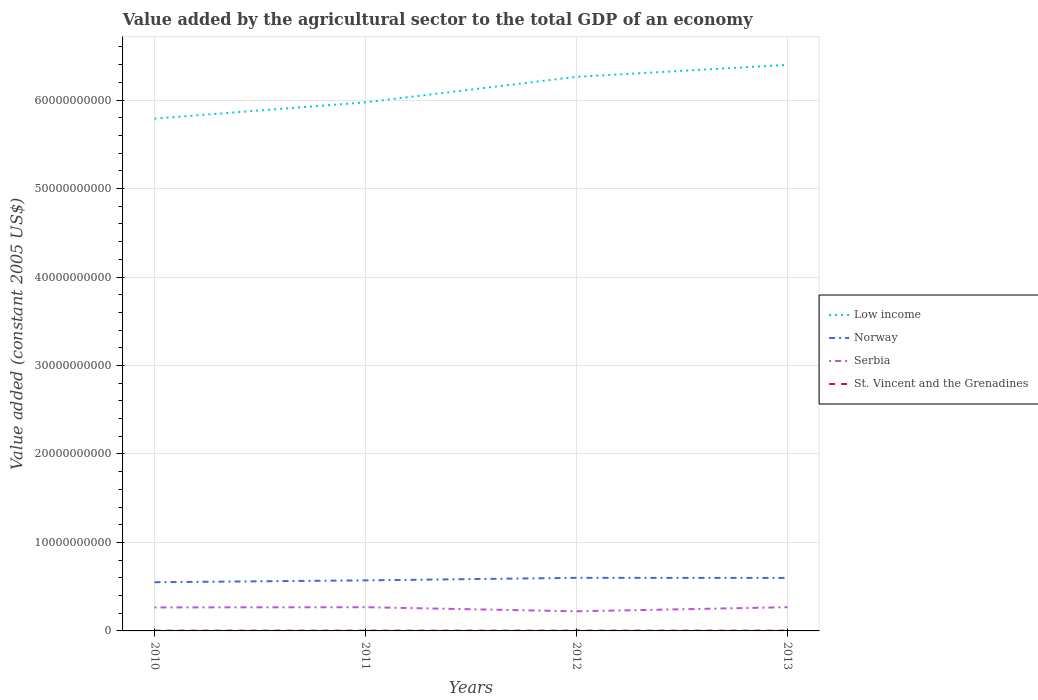Is the number of lines equal to the number of legend labels?
Your answer should be compact. Yes. Across all years, what is the maximum value added by the agricultural sector in Serbia?
Offer a terse response. 2.22e+09. What is the total value added by the agricultural sector in Norway in the graph?
Provide a short and direct response. -2.09e+08. What is the difference between the highest and the second highest value added by the agricultural sector in St. Vincent and the Grenadines?
Your response must be concise. 2.18e+06. What is the difference between the highest and the lowest value added by the agricultural sector in St. Vincent and the Grenadines?
Keep it short and to the point. 1. Is the value added by the agricultural sector in Norway strictly greater than the value added by the agricultural sector in Serbia over the years?
Offer a very short reply. No. What is the difference between two consecutive major ticks on the Y-axis?
Make the answer very short. 1.00e+1. Are the values on the major ticks of Y-axis written in scientific E-notation?
Keep it short and to the point. No. What is the title of the graph?
Ensure brevity in your answer.  Value added by the agricultural sector to the total GDP of an economy. What is the label or title of the X-axis?
Offer a very short reply. Years. What is the label or title of the Y-axis?
Give a very brief answer. Value added (constant 2005 US$). What is the Value added (constant 2005 US$) of Low income in 2010?
Offer a terse response. 5.79e+1. What is the Value added (constant 2005 US$) of Norway in 2010?
Provide a short and direct response. 5.50e+09. What is the Value added (constant 2005 US$) of Serbia in 2010?
Provide a short and direct response. 2.66e+09. What is the Value added (constant 2005 US$) of St. Vincent and the Grenadines in 2010?
Your answer should be very brief. 3.16e+07. What is the Value added (constant 2005 US$) in Low income in 2011?
Your response must be concise. 5.97e+1. What is the Value added (constant 2005 US$) of Norway in 2011?
Offer a very short reply. 5.71e+09. What is the Value added (constant 2005 US$) in Serbia in 2011?
Your answer should be very brief. 2.68e+09. What is the Value added (constant 2005 US$) of St. Vincent and the Grenadines in 2011?
Your response must be concise. 3.15e+07. What is the Value added (constant 2005 US$) in Low income in 2012?
Offer a very short reply. 6.26e+1. What is the Value added (constant 2005 US$) in Norway in 2012?
Ensure brevity in your answer.  6.00e+09. What is the Value added (constant 2005 US$) of Serbia in 2012?
Offer a terse response. 2.22e+09. What is the Value added (constant 2005 US$) of St. Vincent and the Grenadines in 2012?
Offer a very short reply. 3.18e+07. What is the Value added (constant 2005 US$) in Low income in 2013?
Give a very brief answer. 6.40e+1. What is the Value added (constant 2005 US$) of Norway in 2013?
Give a very brief answer. 5.99e+09. What is the Value added (constant 2005 US$) in Serbia in 2013?
Your response must be concise. 2.68e+09. What is the Value added (constant 2005 US$) in St. Vincent and the Grenadines in 2013?
Make the answer very short. 3.37e+07. Across all years, what is the maximum Value added (constant 2005 US$) of Low income?
Your answer should be very brief. 6.40e+1. Across all years, what is the maximum Value added (constant 2005 US$) in Norway?
Provide a succinct answer. 6.00e+09. Across all years, what is the maximum Value added (constant 2005 US$) in Serbia?
Ensure brevity in your answer.  2.68e+09. Across all years, what is the maximum Value added (constant 2005 US$) of St. Vincent and the Grenadines?
Give a very brief answer. 3.37e+07. Across all years, what is the minimum Value added (constant 2005 US$) in Low income?
Provide a short and direct response. 5.79e+1. Across all years, what is the minimum Value added (constant 2005 US$) of Norway?
Make the answer very short. 5.50e+09. Across all years, what is the minimum Value added (constant 2005 US$) of Serbia?
Give a very brief answer. 2.22e+09. Across all years, what is the minimum Value added (constant 2005 US$) in St. Vincent and the Grenadines?
Provide a short and direct response. 3.15e+07. What is the total Value added (constant 2005 US$) of Low income in the graph?
Offer a terse response. 2.44e+11. What is the total Value added (constant 2005 US$) of Norway in the graph?
Offer a terse response. 2.32e+1. What is the total Value added (constant 2005 US$) of Serbia in the graph?
Your response must be concise. 1.02e+1. What is the total Value added (constant 2005 US$) in St. Vincent and the Grenadines in the graph?
Your answer should be compact. 1.29e+08. What is the difference between the Value added (constant 2005 US$) in Low income in 2010 and that in 2011?
Keep it short and to the point. -1.84e+09. What is the difference between the Value added (constant 2005 US$) in Norway in 2010 and that in 2011?
Ensure brevity in your answer.  -2.09e+08. What is the difference between the Value added (constant 2005 US$) in Serbia in 2010 and that in 2011?
Offer a very short reply. -2.52e+07. What is the difference between the Value added (constant 2005 US$) in St. Vincent and the Grenadines in 2010 and that in 2011?
Offer a very short reply. 5.09e+04. What is the difference between the Value added (constant 2005 US$) of Low income in 2010 and that in 2012?
Offer a very short reply. -4.72e+09. What is the difference between the Value added (constant 2005 US$) in Norway in 2010 and that in 2012?
Give a very brief answer. -4.95e+08. What is the difference between the Value added (constant 2005 US$) in Serbia in 2010 and that in 2012?
Provide a succinct answer. 4.38e+08. What is the difference between the Value added (constant 2005 US$) in St. Vincent and the Grenadines in 2010 and that in 2012?
Provide a succinct answer. -2.66e+05. What is the difference between the Value added (constant 2005 US$) in Low income in 2010 and that in 2013?
Ensure brevity in your answer.  -6.07e+09. What is the difference between the Value added (constant 2005 US$) in Norway in 2010 and that in 2013?
Offer a terse response. -4.85e+08. What is the difference between the Value added (constant 2005 US$) in Serbia in 2010 and that in 2013?
Provide a short and direct response. -2.53e+07. What is the difference between the Value added (constant 2005 US$) in St. Vincent and the Grenadines in 2010 and that in 2013?
Offer a very short reply. -2.13e+06. What is the difference between the Value added (constant 2005 US$) in Low income in 2011 and that in 2012?
Keep it short and to the point. -2.88e+09. What is the difference between the Value added (constant 2005 US$) of Norway in 2011 and that in 2012?
Offer a terse response. -2.86e+08. What is the difference between the Value added (constant 2005 US$) of Serbia in 2011 and that in 2012?
Provide a short and direct response. 4.64e+08. What is the difference between the Value added (constant 2005 US$) of St. Vincent and the Grenadines in 2011 and that in 2012?
Keep it short and to the point. -3.17e+05. What is the difference between the Value added (constant 2005 US$) in Low income in 2011 and that in 2013?
Offer a terse response. -4.23e+09. What is the difference between the Value added (constant 2005 US$) in Norway in 2011 and that in 2013?
Give a very brief answer. -2.76e+08. What is the difference between the Value added (constant 2005 US$) of Serbia in 2011 and that in 2013?
Provide a succinct answer. -1.08e+05. What is the difference between the Value added (constant 2005 US$) of St. Vincent and the Grenadines in 2011 and that in 2013?
Offer a very short reply. -2.18e+06. What is the difference between the Value added (constant 2005 US$) of Low income in 2012 and that in 2013?
Give a very brief answer. -1.35e+09. What is the difference between the Value added (constant 2005 US$) in Norway in 2012 and that in 2013?
Keep it short and to the point. 9.78e+06. What is the difference between the Value added (constant 2005 US$) in Serbia in 2012 and that in 2013?
Your answer should be compact. -4.64e+08. What is the difference between the Value added (constant 2005 US$) in St. Vincent and the Grenadines in 2012 and that in 2013?
Make the answer very short. -1.86e+06. What is the difference between the Value added (constant 2005 US$) in Low income in 2010 and the Value added (constant 2005 US$) in Norway in 2011?
Provide a short and direct response. 5.22e+1. What is the difference between the Value added (constant 2005 US$) of Low income in 2010 and the Value added (constant 2005 US$) of Serbia in 2011?
Ensure brevity in your answer.  5.52e+1. What is the difference between the Value added (constant 2005 US$) in Low income in 2010 and the Value added (constant 2005 US$) in St. Vincent and the Grenadines in 2011?
Offer a terse response. 5.79e+1. What is the difference between the Value added (constant 2005 US$) in Norway in 2010 and the Value added (constant 2005 US$) in Serbia in 2011?
Provide a short and direct response. 2.82e+09. What is the difference between the Value added (constant 2005 US$) of Norway in 2010 and the Value added (constant 2005 US$) of St. Vincent and the Grenadines in 2011?
Make the answer very short. 5.47e+09. What is the difference between the Value added (constant 2005 US$) in Serbia in 2010 and the Value added (constant 2005 US$) in St. Vincent and the Grenadines in 2011?
Provide a short and direct response. 2.62e+09. What is the difference between the Value added (constant 2005 US$) of Low income in 2010 and the Value added (constant 2005 US$) of Norway in 2012?
Give a very brief answer. 5.19e+1. What is the difference between the Value added (constant 2005 US$) of Low income in 2010 and the Value added (constant 2005 US$) of Serbia in 2012?
Your answer should be very brief. 5.57e+1. What is the difference between the Value added (constant 2005 US$) of Low income in 2010 and the Value added (constant 2005 US$) of St. Vincent and the Grenadines in 2012?
Offer a terse response. 5.79e+1. What is the difference between the Value added (constant 2005 US$) of Norway in 2010 and the Value added (constant 2005 US$) of Serbia in 2012?
Your answer should be compact. 3.29e+09. What is the difference between the Value added (constant 2005 US$) in Norway in 2010 and the Value added (constant 2005 US$) in St. Vincent and the Grenadines in 2012?
Provide a short and direct response. 5.47e+09. What is the difference between the Value added (constant 2005 US$) of Serbia in 2010 and the Value added (constant 2005 US$) of St. Vincent and the Grenadines in 2012?
Your response must be concise. 2.62e+09. What is the difference between the Value added (constant 2005 US$) in Low income in 2010 and the Value added (constant 2005 US$) in Norway in 2013?
Provide a short and direct response. 5.19e+1. What is the difference between the Value added (constant 2005 US$) in Low income in 2010 and the Value added (constant 2005 US$) in Serbia in 2013?
Your answer should be compact. 5.52e+1. What is the difference between the Value added (constant 2005 US$) of Low income in 2010 and the Value added (constant 2005 US$) of St. Vincent and the Grenadines in 2013?
Your response must be concise. 5.79e+1. What is the difference between the Value added (constant 2005 US$) in Norway in 2010 and the Value added (constant 2005 US$) in Serbia in 2013?
Your answer should be very brief. 2.82e+09. What is the difference between the Value added (constant 2005 US$) of Norway in 2010 and the Value added (constant 2005 US$) of St. Vincent and the Grenadines in 2013?
Make the answer very short. 5.47e+09. What is the difference between the Value added (constant 2005 US$) in Serbia in 2010 and the Value added (constant 2005 US$) in St. Vincent and the Grenadines in 2013?
Your answer should be compact. 2.62e+09. What is the difference between the Value added (constant 2005 US$) in Low income in 2011 and the Value added (constant 2005 US$) in Norway in 2012?
Ensure brevity in your answer.  5.37e+1. What is the difference between the Value added (constant 2005 US$) of Low income in 2011 and the Value added (constant 2005 US$) of Serbia in 2012?
Your answer should be very brief. 5.75e+1. What is the difference between the Value added (constant 2005 US$) in Low income in 2011 and the Value added (constant 2005 US$) in St. Vincent and the Grenadines in 2012?
Provide a short and direct response. 5.97e+1. What is the difference between the Value added (constant 2005 US$) of Norway in 2011 and the Value added (constant 2005 US$) of Serbia in 2012?
Your answer should be very brief. 3.50e+09. What is the difference between the Value added (constant 2005 US$) of Norway in 2011 and the Value added (constant 2005 US$) of St. Vincent and the Grenadines in 2012?
Keep it short and to the point. 5.68e+09. What is the difference between the Value added (constant 2005 US$) in Serbia in 2011 and the Value added (constant 2005 US$) in St. Vincent and the Grenadines in 2012?
Give a very brief answer. 2.65e+09. What is the difference between the Value added (constant 2005 US$) of Low income in 2011 and the Value added (constant 2005 US$) of Norway in 2013?
Ensure brevity in your answer.  5.38e+1. What is the difference between the Value added (constant 2005 US$) of Low income in 2011 and the Value added (constant 2005 US$) of Serbia in 2013?
Keep it short and to the point. 5.71e+1. What is the difference between the Value added (constant 2005 US$) in Low income in 2011 and the Value added (constant 2005 US$) in St. Vincent and the Grenadines in 2013?
Ensure brevity in your answer.  5.97e+1. What is the difference between the Value added (constant 2005 US$) of Norway in 2011 and the Value added (constant 2005 US$) of Serbia in 2013?
Your answer should be compact. 3.03e+09. What is the difference between the Value added (constant 2005 US$) of Norway in 2011 and the Value added (constant 2005 US$) of St. Vincent and the Grenadines in 2013?
Provide a succinct answer. 5.68e+09. What is the difference between the Value added (constant 2005 US$) in Serbia in 2011 and the Value added (constant 2005 US$) in St. Vincent and the Grenadines in 2013?
Provide a succinct answer. 2.65e+09. What is the difference between the Value added (constant 2005 US$) in Low income in 2012 and the Value added (constant 2005 US$) in Norway in 2013?
Your answer should be very brief. 5.66e+1. What is the difference between the Value added (constant 2005 US$) in Low income in 2012 and the Value added (constant 2005 US$) in Serbia in 2013?
Provide a short and direct response. 5.99e+1. What is the difference between the Value added (constant 2005 US$) of Low income in 2012 and the Value added (constant 2005 US$) of St. Vincent and the Grenadines in 2013?
Provide a succinct answer. 6.26e+1. What is the difference between the Value added (constant 2005 US$) of Norway in 2012 and the Value added (constant 2005 US$) of Serbia in 2013?
Offer a very short reply. 3.32e+09. What is the difference between the Value added (constant 2005 US$) in Norway in 2012 and the Value added (constant 2005 US$) in St. Vincent and the Grenadines in 2013?
Ensure brevity in your answer.  5.97e+09. What is the difference between the Value added (constant 2005 US$) of Serbia in 2012 and the Value added (constant 2005 US$) of St. Vincent and the Grenadines in 2013?
Your answer should be very brief. 2.18e+09. What is the average Value added (constant 2005 US$) of Low income per year?
Your response must be concise. 6.11e+1. What is the average Value added (constant 2005 US$) of Norway per year?
Offer a very short reply. 5.80e+09. What is the average Value added (constant 2005 US$) in Serbia per year?
Your response must be concise. 2.56e+09. What is the average Value added (constant 2005 US$) in St. Vincent and the Grenadines per year?
Offer a terse response. 3.21e+07. In the year 2010, what is the difference between the Value added (constant 2005 US$) of Low income and Value added (constant 2005 US$) of Norway?
Offer a terse response. 5.24e+1. In the year 2010, what is the difference between the Value added (constant 2005 US$) of Low income and Value added (constant 2005 US$) of Serbia?
Provide a succinct answer. 5.52e+1. In the year 2010, what is the difference between the Value added (constant 2005 US$) in Low income and Value added (constant 2005 US$) in St. Vincent and the Grenadines?
Ensure brevity in your answer.  5.79e+1. In the year 2010, what is the difference between the Value added (constant 2005 US$) in Norway and Value added (constant 2005 US$) in Serbia?
Your response must be concise. 2.85e+09. In the year 2010, what is the difference between the Value added (constant 2005 US$) in Norway and Value added (constant 2005 US$) in St. Vincent and the Grenadines?
Ensure brevity in your answer.  5.47e+09. In the year 2010, what is the difference between the Value added (constant 2005 US$) in Serbia and Value added (constant 2005 US$) in St. Vincent and the Grenadines?
Offer a terse response. 2.62e+09. In the year 2011, what is the difference between the Value added (constant 2005 US$) in Low income and Value added (constant 2005 US$) in Norway?
Your answer should be compact. 5.40e+1. In the year 2011, what is the difference between the Value added (constant 2005 US$) of Low income and Value added (constant 2005 US$) of Serbia?
Your answer should be compact. 5.71e+1. In the year 2011, what is the difference between the Value added (constant 2005 US$) of Low income and Value added (constant 2005 US$) of St. Vincent and the Grenadines?
Keep it short and to the point. 5.97e+1. In the year 2011, what is the difference between the Value added (constant 2005 US$) in Norway and Value added (constant 2005 US$) in Serbia?
Provide a short and direct response. 3.03e+09. In the year 2011, what is the difference between the Value added (constant 2005 US$) in Norway and Value added (constant 2005 US$) in St. Vincent and the Grenadines?
Keep it short and to the point. 5.68e+09. In the year 2011, what is the difference between the Value added (constant 2005 US$) in Serbia and Value added (constant 2005 US$) in St. Vincent and the Grenadines?
Offer a very short reply. 2.65e+09. In the year 2012, what is the difference between the Value added (constant 2005 US$) in Low income and Value added (constant 2005 US$) in Norway?
Keep it short and to the point. 5.66e+1. In the year 2012, what is the difference between the Value added (constant 2005 US$) in Low income and Value added (constant 2005 US$) in Serbia?
Provide a succinct answer. 6.04e+1. In the year 2012, what is the difference between the Value added (constant 2005 US$) in Low income and Value added (constant 2005 US$) in St. Vincent and the Grenadines?
Ensure brevity in your answer.  6.26e+1. In the year 2012, what is the difference between the Value added (constant 2005 US$) of Norway and Value added (constant 2005 US$) of Serbia?
Keep it short and to the point. 3.78e+09. In the year 2012, what is the difference between the Value added (constant 2005 US$) in Norway and Value added (constant 2005 US$) in St. Vincent and the Grenadines?
Your response must be concise. 5.97e+09. In the year 2012, what is the difference between the Value added (constant 2005 US$) in Serbia and Value added (constant 2005 US$) in St. Vincent and the Grenadines?
Keep it short and to the point. 2.19e+09. In the year 2013, what is the difference between the Value added (constant 2005 US$) of Low income and Value added (constant 2005 US$) of Norway?
Provide a succinct answer. 5.80e+1. In the year 2013, what is the difference between the Value added (constant 2005 US$) in Low income and Value added (constant 2005 US$) in Serbia?
Provide a succinct answer. 6.13e+1. In the year 2013, what is the difference between the Value added (constant 2005 US$) in Low income and Value added (constant 2005 US$) in St. Vincent and the Grenadines?
Offer a terse response. 6.39e+1. In the year 2013, what is the difference between the Value added (constant 2005 US$) of Norway and Value added (constant 2005 US$) of Serbia?
Provide a short and direct response. 3.31e+09. In the year 2013, what is the difference between the Value added (constant 2005 US$) of Norway and Value added (constant 2005 US$) of St. Vincent and the Grenadines?
Ensure brevity in your answer.  5.96e+09. In the year 2013, what is the difference between the Value added (constant 2005 US$) in Serbia and Value added (constant 2005 US$) in St. Vincent and the Grenadines?
Ensure brevity in your answer.  2.65e+09. What is the ratio of the Value added (constant 2005 US$) of Low income in 2010 to that in 2011?
Your answer should be compact. 0.97. What is the ratio of the Value added (constant 2005 US$) in Norway in 2010 to that in 2011?
Provide a succinct answer. 0.96. What is the ratio of the Value added (constant 2005 US$) of Serbia in 2010 to that in 2011?
Your answer should be compact. 0.99. What is the ratio of the Value added (constant 2005 US$) of St. Vincent and the Grenadines in 2010 to that in 2011?
Offer a very short reply. 1. What is the ratio of the Value added (constant 2005 US$) in Low income in 2010 to that in 2012?
Give a very brief answer. 0.92. What is the ratio of the Value added (constant 2005 US$) of Norway in 2010 to that in 2012?
Provide a short and direct response. 0.92. What is the ratio of the Value added (constant 2005 US$) of Serbia in 2010 to that in 2012?
Make the answer very short. 1.2. What is the ratio of the Value added (constant 2005 US$) in St. Vincent and the Grenadines in 2010 to that in 2012?
Offer a terse response. 0.99. What is the ratio of the Value added (constant 2005 US$) of Low income in 2010 to that in 2013?
Offer a terse response. 0.91. What is the ratio of the Value added (constant 2005 US$) in Norway in 2010 to that in 2013?
Give a very brief answer. 0.92. What is the ratio of the Value added (constant 2005 US$) in Serbia in 2010 to that in 2013?
Provide a short and direct response. 0.99. What is the ratio of the Value added (constant 2005 US$) in St. Vincent and the Grenadines in 2010 to that in 2013?
Offer a terse response. 0.94. What is the ratio of the Value added (constant 2005 US$) in Low income in 2011 to that in 2012?
Your response must be concise. 0.95. What is the ratio of the Value added (constant 2005 US$) of Norway in 2011 to that in 2012?
Give a very brief answer. 0.95. What is the ratio of the Value added (constant 2005 US$) of Serbia in 2011 to that in 2012?
Your answer should be very brief. 1.21. What is the ratio of the Value added (constant 2005 US$) in Low income in 2011 to that in 2013?
Your answer should be very brief. 0.93. What is the ratio of the Value added (constant 2005 US$) in Norway in 2011 to that in 2013?
Give a very brief answer. 0.95. What is the ratio of the Value added (constant 2005 US$) in Serbia in 2011 to that in 2013?
Provide a short and direct response. 1. What is the ratio of the Value added (constant 2005 US$) in St. Vincent and the Grenadines in 2011 to that in 2013?
Offer a very short reply. 0.94. What is the ratio of the Value added (constant 2005 US$) of Low income in 2012 to that in 2013?
Provide a succinct answer. 0.98. What is the ratio of the Value added (constant 2005 US$) in Norway in 2012 to that in 2013?
Provide a short and direct response. 1. What is the ratio of the Value added (constant 2005 US$) of Serbia in 2012 to that in 2013?
Keep it short and to the point. 0.83. What is the ratio of the Value added (constant 2005 US$) of St. Vincent and the Grenadines in 2012 to that in 2013?
Provide a succinct answer. 0.94. What is the difference between the highest and the second highest Value added (constant 2005 US$) of Low income?
Offer a very short reply. 1.35e+09. What is the difference between the highest and the second highest Value added (constant 2005 US$) of Norway?
Offer a terse response. 9.78e+06. What is the difference between the highest and the second highest Value added (constant 2005 US$) of Serbia?
Your response must be concise. 1.08e+05. What is the difference between the highest and the second highest Value added (constant 2005 US$) of St. Vincent and the Grenadines?
Make the answer very short. 1.86e+06. What is the difference between the highest and the lowest Value added (constant 2005 US$) in Low income?
Your response must be concise. 6.07e+09. What is the difference between the highest and the lowest Value added (constant 2005 US$) in Norway?
Keep it short and to the point. 4.95e+08. What is the difference between the highest and the lowest Value added (constant 2005 US$) in Serbia?
Ensure brevity in your answer.  4.64e+08. What is the difference between the highest and the lowest Value added (constant 2005 US$) of St. Vincent and the Grenadines?
Your response must be concise. 2.18e+06. 